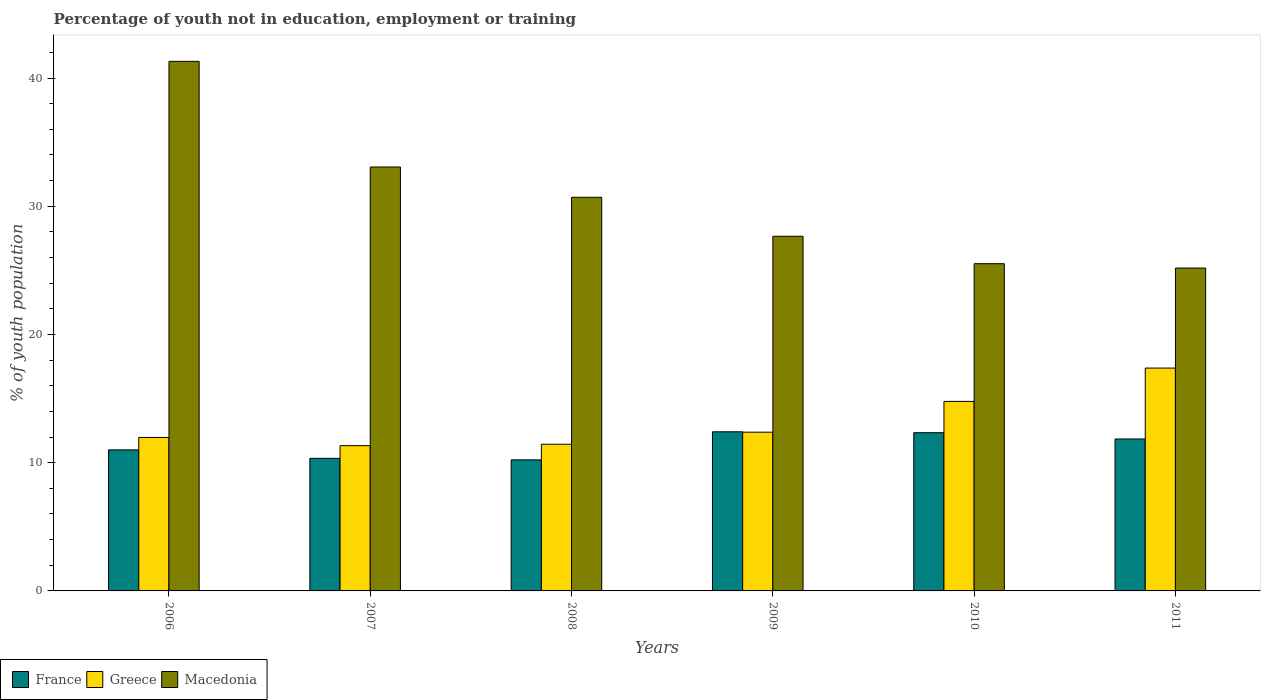How many different coloured bars are there?
Your response must be concise. 3. Are the number of bars per tick equal to the number of legend labels?
Offer a very short reply. Yes. What is the percentage of unemployed youth population in in Greece in 2007?
Give a very brief answer. 11.33. Across all years, what is the maximum percentage of unemployed youth population in in France?
Your answer should be compact. 12.41. Across all years, what is the minimum percentage of unemployed youth population in in Greece?
Make the answer very short. 11.33. What is the total percentage of unemployed youth population in in Greece in the graph?
Provide a short and direct response. 79.28. What is the difference between the percentage of unemployed youth population in in Greece in 2006 and that in 2010?
Provide a short and direct response. -2.81. What is the difference between the percentage of unemployed youth population in in Greece in 2011 and the percentage of unemployed youth population in in Macedonia in 2009?
Your response must be concise. -10.28. What is the average percentage of unemployed youth population in in Macedonia per year?
Offer a terse response. 30.57. In the year 2011, what is the difference between the percentage of unemployed youth population in in Greece and percentage of unemployed youth population in in France?
Your answer should be compact. 5.53. In how many years, is the percentage of unemployed youth population in in Greece greater than 24 %?
Your answer should be very brief. 0. What is the ratio of the percentage of unemployed youth population in in Macedonia in 2006 to that in 2009?
Offer a very short reply. 1.49. Is the difference between the percentage of unemployed youth population in in Greece in 2006 and 2007 greater than the difference between the percentage of unemployed youth population in in France in 2006 and 2007?
Keep it short and to the point. No. What is the difference between the highest and the second highest percentage of unemployed youth population in in Macedonia?
Make the answer very short. 8.24. What is the difference between the highest and the lowest percentage of unemployed youth population in in France?
Keep it short and to the point. 2.19. Is the sum of the percentage of unemployed youth population in in Macedonia in 2006 and 2009 greater than the maximum percentage of unemployed youth population in in Greece across all years?
Make the answer very short. Yes. What does the 1st bar from the left in 2006 represents?
Your answer should be very brief. France. Is it the case that in every year, the sum of the percentage of unemployed youth population in in Greece and percentage of unemployed youth population in in Macedonia is greater than the percentage of unemployed youth population in in France?
Your response must be concise. Yes. How many bars are there?
Ensure brevity in your answer.  18. Are all the bars in the graph horizontal?
Your answer should be compact. No. How many years are there in the graph?
Give a very brief answer. 6. What is the difference between two consecutive major ticks on the Y-axis?
Ensure brevity in your answer.  10. Does the graph contain any zero values?
Give a very brief answer. No. Where does the legend appear in the graph?
Your answer should be very brief. Bottom left. How many legend labels are there?
Your answer should be compact. 3. How are the legend labels stacked?
Provide a succinct answer. Horizontal. What is the title of the graph?
Ensure brevity in your answer.  Percentage of youth not in education, employment or training. What is the label or title of the X-axis?
Keep it short and to the point. Years. What is the label or title of the Y-axis?
Provide a short and direct response. % of youth population. What is the % of youth population of Greece in 2006?
Give a very brief answer. 11.97. What is the % of youth population of Macedonia in 2006?
Make the answer very short. 41.3. What is the % of youth population of France in 2007?
Offer a very short reply. 10.34. What is the % of youth population of Greece in 2007?
Your answer should be very brief. 11.33. What is the % of youth population in Macedonia in 2007?
Your answer should be compact. 33.06. What is the % of youth population in France in 2008?
Give a very brief answer. 10.22. What is the % of youth population of Greece in 2008?
Keep it short and to the point. 11.44. What is the % of youth population in Macedonia in 2008?
Provide a short and direct response. 30.7. What is the % of youth population of France in 2009?
Your answer should be compact. 12.41. What is the % of youth population in Greece in 2009?
Provide a succinct answer. 12.38. What is the % of youth population of Macedonia in 2009?
Your answer should be very brief. 27.66. What is the % of youth population of France in 2010?
Give a very brief answer. 12.34. What is the % of youth population in Greece in 2010?
Your answer should be compact. 14.78. What is the % of youth population of Macedonia in 2010?
Ensure brevity in your answer.  25.52. What is the % of youth population of France in 2011?
Offer a terse response. 11.85. What is the % of youth population in Greece in 2011?
Your response must be concise. 17.38. What is the % of youth population in Macedonia in 2011?
Keep it short and to the point. 25.18. Across all years, what is the maximum % of youth population in France?
Provide a short and direct response. 12.41. Across all years, what is the maximum % of youth population of Greece?
Keep it short and to the point. 17.38. Across all years, what is the maximum % of youth population of Macedonia?
Provide a short and direct response. 41.3. Across all years, what is the minimum % of youth population of France?
Your answer should be compact. 10.22. Across all years, what is the minimum % of youth population in Greece?
Your response must be concise. 11.33. Across all years, what is the minimum % of youth population in Macedonia?
Keep it short and to the point. 25.18. What is the total % of youth population of France in the graph?
Ensure brevity in your answer.  68.16. What is the total % of youth population of Greece in the graph?
Keep it short and to the point. 79.28. What is the total % of youth population in Macedonia in the graph?
Offer a very short reply. 183.42. What is the difference between the % of youth population of France in 2006 and that in 2007?
Offer a terse response. 0.66. What is the difference between the % of youth population of Greece in 2006 and that in 2007?
Your answer should be compact. 0.64. What is the difference between the % of youth population of Macedonia in 2006 and that in 2007?
Your response must be concise. 8.24. What is the difference between the % of youth population of France in 2006 and that in 2008?
Offer a terse response. 0.78. What is the difference between the % of youth population in Greece in 2006 and that in 2008?
Your response must be concise. 0.53. What is the difference between the % of youth population in Macedonia in 2006 and that in 2008?
Your answer should be compact. 10.6. What is the difference between the % of youth population in France in 2006 and that in 2009?
Ensure brevity in your answer.  -1.41. What is the difference between the % of youth population of Greece in 2006 and that in 2009?
Offer a very short reply. -0.41. What is the difference between the % of youth population of Macedonia in 2006 and that in 2009?
Provide a succinct answer. 13.64. What is the difference between the % of youth population in France in 2006 and that in 2010?
Make the answer very short. -1.34. What is the difference between the % of youth population in Greece in 2006 and that in 2010?
Your response must be concise. -2.81. What is the difference between the % of youth population in Macedonia in 2006 and that in 2010?
Offer a terse response. 15.78. What is the difference between the % of youth population in France in 2006 and that in 2011?
Make the answer very short. -0.85. What is the difference between the % of youth population of Greece in 2006 and that in 2011?
Your response must be concise. -5.41. What is the difference between the % of youth population in Macedonia in 2006 and that in 2011?
Make the answer very short. 16.12. What is the difference between the % of youth population in France in 2007 and that in 2008?
Ensure brevity in your answer.  0.12. What is the difference between the % of youth population of Greece in 2007 and that in 2008?
Keep it short and to the point. -0.11. What is the difference between the % of youth population of Macedonia in 2007 and that in 2008?
Ensure brevity in your answer.  2.36. What is the difference between the % of youth population in France in 2007 and that in 2009?
Offer a terse response. -2.07. What is the difference between the % of youth population in Greece in 2007 and that in 2009?
Ensure brevity in your answer.  -1.05. What is the difference between the % of youth population in France in 2007 and that in 2010?
Your answer should be compact. -2. What is the difference between the % of youth population of Greece in 2007 and that in 2010?
Your response must be concise. -3.45. What is the difference between the % of youth population of Macedonia in 2007 and that in 2010?
Offer a very short reply. 7.54. What is the difference between the % of youth population in France in 2007 and that in 2011?
Keep it short and to the point. -1.51. What is the difference between the % of youth population in Greece in 2007 and that in 2011?
Offer a terse response. -6.05. What is the difference between the % of youth population of Macedonia in 2007 and that in 2011?
Ensure brevity in your answer.  7.88. What is the difference between the % of youth population in France in 2008 and that in 2009?
Provide a succinct answer. -2.19. What is the difference between the % of youth population of Greece in 2008 and that in 2009?
Ensure brevity in your answer.  -0.94. What is the difference between the % of youth population in Macedonia in 2008 and that in 2009?
Give a very brief answer. 3.04. What is the difference between the % of youth population of France in 2008 and that in 2010?
Your answer should be compact. -2.12. What is the difference between the % of youth population in Greece in 2008 and that in 2010?
Provide a short and direct response. -3.34. What is the difference between the % of youth population in Macedonia in 2008 and that in 2010?
Provide a short and direct response. 5.18. What is the difference between the % of youth population in France in 2008 and that in 2011?
Provide a succinct answer. -1.63. What is the difference between the % of youth population in Greece in 2008 and that in 2011?
Make the answer very short. -5.94. What is the difference between the % of youth population of Macedonia in 2008 and that in 2011?
Offer a very short reply. 5.52. What is the difference between the % of youth population of France in 2009 and that in 2010?
Ensure brevity in your answer.  0.07. What is the difference between the % of youth population in Macedonia in 2009 and that in 2010?
Make the answer very short. 2.14. What is the difference between the % of youth population in France in 2009 and that in 2011?
Provide a succinct answer. 0.56. What is the difference between the % of youth population of Greece in 2009 and that in 2011?
Your response must be concise. -5. What is the difference between the % of youth population of Macedonia in 2009 and that in 2011?
Your answer should be compact. 2.48. What is the difference between the % of youth population of France in 2010 and that in 2011?
Offer a terse response. 0.49. What is the difference between the % of youth population of Macedonia in 2010 and that in 2011?
Keep it short and to the point. 0.34. What is the difference between the % of youth population in France in 2006 and the % of youth population in Greece in 2007?
Provide a short and direct response. -0.33. What is the difference between the % of youth population of France in 2006 and the % of youth population of Macedonia in 2007?
Ensure brevity in your answer.  -22.06. What is the difference between the % of youth population of Greece in 2006 and the % of youth population of Macedonia in 2007?
Offer a terse response. -21.09. What is the difference between the % of youth population of France in 2006 and the % of youth population of Greece in 2008?
Provide a short and direct response. -0.44. What is the difference between the % of youth population of France in 2006 and the % of youth population of Macedonia in 2008?
Your answer should be compact. -19.7. What is the difference between the % of youth population in Greece in 2006 and the % of youth population in Macedonia in 2008?
Keep it short and to the point. -18.73. What is the difference between the % of youth population in France in 2006 and the % of youth population in Greece in 2009?
Make the answer very short. -1.38. What is the difference between the % of youth population in France in 2006 and the % of youth population in Macedonia in 2009?
Your response must be concise. -16.66. What is the difference between the % of youth population in Greece in 2006 and the % of youth population in Macedonia in 2009?
Provide a short and direct response. -15.69. What is the difference between the % of youth population in France in 2006 and the % of youth population in Greece in 2010?
Offer a very short reply. -3.78. What is the difference between the % of youth population in France in 2006 and the % of youth population in Macedonia in 2010?
Ensure brevity in your answer.  -14.52. What is the difference between the % of youth population in Greece in 2006 and the % of youth population in Macedonia in 2010?
Keep it short and to the point. -13.55. What is the difference between the % of youth population of France in 2006 and the % of youth population of Greece in 2011?
Your answer should be compact. -6.38. What is the difference between the % of youth population of France in 2006 and the % of youth population of Macedonia in 2011?
Keep it short and to the point. -14.18. What is the difference between the % of youth population in Greece in 2006 and the % of youth population in Macedonia in 2011?
Your answer should be compact. -13.21. What is the difference between the % of youth population in France in 2007 and the % of youth population in Macedonia in 2008?
Your answer should be very brief. -20.36. What is the difference between the % of youth population in Greece in 2007 and the % of youth population in Macedonia in 2008?
Give a very brief answer. -19.37. What is the difference between the % of youth population in France in 2007 and the % of youth population in Greece in 2009?
Offer a terse response. -2.04. What is the difference between the % of youth population of France in 2007 and the % of youth population of Macedonia in 2009?
Offer a terse response. -17.32. What is the difference between the % of youth population of Greece in 2007 and the % of youth population of Macedonia in 2009?
Your answer should be compact. -16.33. What is the difference between the % of youth population in France in 2007 and the % of youth population in Greece in 2010?
Give a very brief answer. -4.44. What is the difference between the % of youth population in France in 2007 and the % of youth population in Macedonia in 2010?
Make the answer very short. -15.18. What is the difference between the % of youth population of Greece in 2007 and the % of youth population of Macedonia in 2010?
Provide a short and direct response. -14.19. What is the difference between the % of youth population in France in 2007 and the % of youth population in Greece in 2011?
Your answer should be compact. -7.04. What is the difference between the % of youth population of France in 2007 and the % of youth population of Macedonia in 2011?
Your response must be concise. -14.84. What is the difference between the % of youth population of Greece in 2007 and the % of youth population of Macedonia in 2011?
Make the answer very short. -13.85. What is the difference between the % of youth population in France in 2008 and the % of youth population in Greece in 2009?
Offer a very short reply. -2.16. What is the difference between the % of youth population in France in 2008 and the % of youth population in Macedonia in 2009?
Your response must be concise. -17.44. What is the difference between the % of youth population in Greece in 2008 and the % of youth population in Macedonia in 2009?
Your answer should be very brief. -16.22. What is the difference between the % of youth population in France in 2008 and the % of youth population in Greece in 2010?
Ensure brevity in your answer.  -4.56. What is the difference between the % of youth population in France in 2008 and the % of youth population in Macedonia in 2010?
Give a very brief answer. -15.3. What is the difference between the % of youth population in Greece in 2008 and the % of youth population in Macedonia in 2010?
Provide a short and direct response. -14.08. What is the difference between the % of youth population in France in 2008 and the % of youth population in Greece in 2011?
Offer a very short reply. -7.16. What is the difference between the % of youth population in France in 2008 and the % of youth population in Macedonia in 2011?
Make the answer very short. -14.96. What is the difference between the % of youth population in Greece in 2008 and the % of youth population in Macedonia in 2011?
Ensure brevity in your answer.  -13.74. What is the difference between the % of youth population of France in 2009 and the % of youth population of Greece in 2010?
Keep it short and to the point. -2.37. What is the difference between the % of youth population in France in 2009 and the % of youth population in Macedonia in 2010?
Give a very brief answer. -13.11. What is the difference between the % of youth population of Greece in 2009 and the % of youth population of Macedonia in 2010?
Your response must be concise. -13.14. What is the difference between the % of youth population of France in 2009 and the % of youth population of Greece in 2011?
Your answer should be very brief. -4.97. What is the difference between the % of youth population of France in 2009 and the % of youth population of Macedonia in 2011?
Ensure brevity in your answer.  -12.77. What is the difference between the % of youth population in France in 2010 and the % of youth population in Greece in 2011?
Your response must be concise. -5.04. What is the difference between the % of youth population in France in 2010 and the % of youth population in Macedonia in 2011?
Provide a succinct answer. -12.84. What is the difference between the % of youth population in Greece in 2010 and the % of youth population in Macedonia in 2011?
Offer a very short reply. -10.4. What is the average % of youth population of France per year?
Your answer should be very brief. 11.36. What is the average % of youth population of Greece per year?
Make the answer very short. 13.21. What is the average % of youth population in Macedonia per year?
Ensure brevity in your answer.  30.57. In the year 2006, what is the difference between the % of youth population of France and % of youth population of Greece?
Provide a short and direct response. -0.97. In the year 2006, what is the difference between the % of youth population in France and % of youth population in Macedonia?
Make the answer very short. -30.3. In the year 2006, what is the difference between the % of youth population of Greece and % of youth population of Macedonia?
Offer a terse response. -29.33. In the year 2007, what is the difference between the % of youth population of France and % of youth population of Greece?
Your response must be concise. -0.99. In the year 2007, what is the difference between the % of youth population in France and % of youth population in Macedonia?
Ensure brevity in your answer.  -22.72. In the year 2007, what is the difference between the % of youth population of Greece and % of youth population of Macedonia?
Make the answer very short. -21.73. In the year 2008, what is the difference between the % of youth population in France and % of youth population in Greece?
Provide a short and direct response. -1.22. In the year 2008, what is the difference between the % of youth population in France and % of youth population in Macedonia?
Provide a short and direct response. -20.48. In the year 2008, what is the difference between the % of youth population in Greece and % of youth population in Macedonia?
Make the answer very short. -19.26. In the year 2009, what is the difference between the % of youth population of France and % of youth population of Greece?
Offer a very short reply. 0.03. In the year 2009, what is the difference between the % of youth population of France and % of youth population of Macedonia?
Make the answer very short. -15.25. In the year 2009, what is the difference between the % of youth population in Greece and % of youth population in Macedonia?
Ensure brevity in your answer.  -15.28. In the year 2010, what is the difference between the % of youth population in France and % of youth population in Greece?
Offer a very short reply. -2.44. In the year 2010, what is the difference between the % of youth population in France and % of youth population in Macedonia?
Make the answer very short. -13.18. In the year 2010, what is the difference between the % of youth population in Greece and % of youth population in Macedonia?
Provide a succinct answer. -10.74. In the year 2011, what is the difference between the % of youth population in France and % of youth population in Greece?
Provide a short and direct response. -5.53. In the year 2011, what is the difference between the % of youth population of France and % of youth population of Macedonia?
Provide a succinct answer. -13.33. In the year 2011, what is the difference between the % of youth population in Greece and % of youth population in Macedonia?
Your answer should be very brief. -7.8. What is the ratio of the % of youth population of France in 2006 to that in 2007?
Offer a very short reply. 1.06. What is the ratio of the % of youth population of Greece in 2006 to that in 2007?
Ensure brevity in your answer.  1.06. What is the ratio of the % of youth population of Macedonia in 2006 to that in 2007?
Provide a succinct answer. 1.25. What is the ratio of the % of youth population in France in 2006 to that in 2008?
Offer a very short reply. 1.08. What is the ratio of the % of youth population of Greece in 2006 to that in 2008?
Give a very brief answer. 1.05. What is the ratio of the % of youth population in Macedonia in 2006 to that in 2008?
Your response must be concise. 1.35. What is the ratio of the % of youth population of France in 2006 to that in 2009?
Offer a very short reply. 0.89. What is the ratio of the % of youth population in Greece in 2006 to that in 2009?
Offer a terse response. 0.97. What is the ratio of the % of youth population of Macedonia in 2006 to that in 2009?
Keep it short and to the point. 1.49. What is the ratio of the % of youth population in France in 2006 to that in 2010?
Your answer should be very brief. 0.89. What is the ratio of the % of youth population of Greece in 2006 to that in 2010?
Offer a terse response. 0.81. What is the ratio of the % of youth population in Macedonia in 2006 to that in 2010?
Provide a short and direct response. 1.62. What is the ratio of the % of youth population in France in 2006 to that in 2011?
Provide a succinct answer. 0.93. What is the ratio of the % of youth population of Greece in 2006 to that in 2011?
Keep it short and to the point. 0.69. What is the ratio of the % of youth population in Macedonia in 2006 to that in 2011?
Ensure brevity in your answer.  1.64. What is the ratio of the % of youth population of France in 2007 to that in 2008?
Provide a succinct answer. 1.01. What is the ratio of the % of youth population in France in 2007 to that in 2009?
Your response must be concise. 0.83. What is the ratio of the % of youth population in Greece in 2007 to that in 2009?
Provide a short and direct response. 0.92. What is the ratio of the % of youth population in Macedonia in 2007 to that in 2009?
Offer a very short reply. 1.2. What is the ratio of the % of youth population in France in 2007 to that in 2010?
Offer a terse response. 0.84. What is the ratio of the % of youth population in Greece in 2007 to that in 2010?
Make the answer very short. 0.77. What is the ratio of the % of youth population in Macedonia in 2007 to that in 2010?
Make the answer very short. 1.3. What is the ratio of the % of youth population in France in 2007 to that in 2011?
Make the answer very short. 0.87. What is the ratio of the % of youth population of Greece in 2007 to that in 2011?
Offer a very short reply. 0.65. What is the ratio of the % of youth population in Macedonia in 2007 to that in 2011?
Your response must be concise. 1.31. What is the ratio of the % of youth population in France in 2008 to that in 2009?
Give a very brief answer. 0.82. What is the ratio of the % of youth population of Greece in 2008 to that in 2009?
Make the answer very short. 0.92. What is the ratio of the % of youth population in Macedonia in 2008 to that in 2009?
Your response must be concise. 1.11. What is the ratio of the % of youth population of France in 2008 to that in 2010?
Offer a very short reply. 0.83. What is the ratio of the % of youth population in Greece in 2008 to that in 2010?
Provide a succinct answer. 0.77. What is the ratio of the % of youth population in Macedonia in 2008 to that in 2010?
Your response must be concise. 1.2. What is the ratio of the % of youth population of France in 2008 to that in 2011?
Provide a succinct answer. 0.86. What is the ratio of the % of youth population of Greece in 2008 to that in 2011?
Provide a succinct answer. 0.66. What is the ratio of the % of youth population in Macedonia in 2008 to that in 2011?
Provide a short and direct response. 1.22. What is the ratio of the % of youth population in France in 2009 to that in 2010?
Your answer should be very brief. 1.01. What is the ratio of the % of youth population of Greece in 2009 to that in 2010?
Your answer should be compact. 0.84. What is the ratio of the % of youth population of Macedonia in 2009 to that in 2010?
Your response must be concise. 1.08. What is the ratio of the % of youth population of France in 2009 to that in 2011?
Offer a very short reply. 1.05. What is the ratio of the % of youth population of Greece in 2009 to that in 2011?
Give a very brief answer. 0.71. What is the ratio of the % of youth population in Macedonia in 2009 to that in 2011?
Offer a very short reply. 1.1. What is the ratio of the % of youth population of France in 2010 to that in 2011?
Your answer should be very brief. 1.04. What is the ratio of the % of youth population in Greece in 2010 to that in 2011?
Offer a very short reply. 0.85. What is the ratio of the % of youth population in Macedonia in 2010 to that in 2011?
Offer a terse response. 1.01. What is the difference between the highest and the second highest % of youth population in France?
Provide a short and direct response. 0.07. What is the difference between the highest and the second highest % of youth population of Greece?
Your response must be concise. 2.6. What is the difference between the highest and the second highest % of youth population of Macedonia?
Ensure brevity in your answer.  8.24. What is the difference between the highest and the lowest % of youth population of France?
Ensure brevity in your answer.  2.19. What is the difference between the highest and the lowest % of youth population of Greece?
Your response must be concise. 6.05. What is the difference between the highest and the lowest % of youth population in Macedonia?
Offer a very short reply. 16.12. 